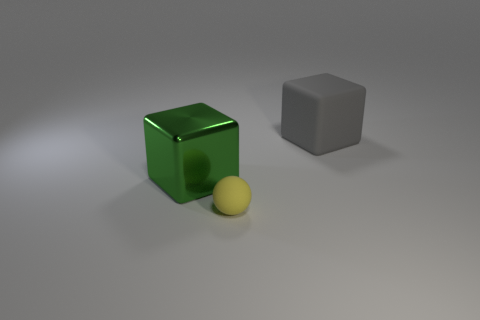Is the shape of the large gray object the same as the thing on the left side of the tiny yellow thing?
Offer a very short reply. Yes. There is a cube that is left of the rubber thing behind the large cube that is in front of the gray matte cube; what is it made of?
Keep it short and to the point. Metal. Are there any yellow rubber objects that have the same size as the sphere?
Keep it short and to the point. No. What is the size of the yellow object that is made of the same material as the large gray object?
Keep it short and to the point. Small. The gray thing has what shape?
Your response must be concise. Cube. Is the small yellow thing made of the same material as the big cube behind the large green thing?
Your answer should be very brief. Yes. What number of things are either green cubes or yellow objects?
Give a very brief answer. 2. Are there any tiny things?
Make the answer very short. Yes. The large object in front of the matte thing right of the matte ball is what shape?
Ensure brevity in your answer.  Cube. How many objects are either big gray things that are behind the yellow rubber thing or metal blocks that are behind the tiny object?
Offer a very short reply. 2. 